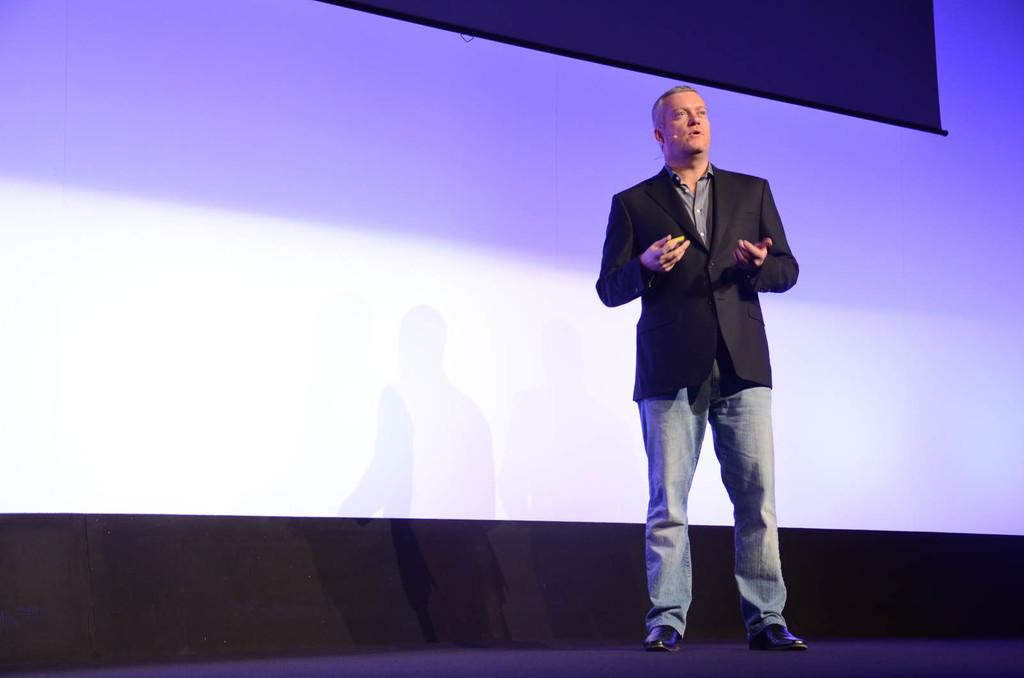Who is present in the image? There is a man in the picture. What is the man doing in the image? The man is talking. What is the man wearing in the image? The man is wearing a coat. What can be seen in the background of the image? There is a projector screen in the background of the image. What type of scissors can be seen in the man's hand in the image? There are no scissors present in the man's hand or in the image. 